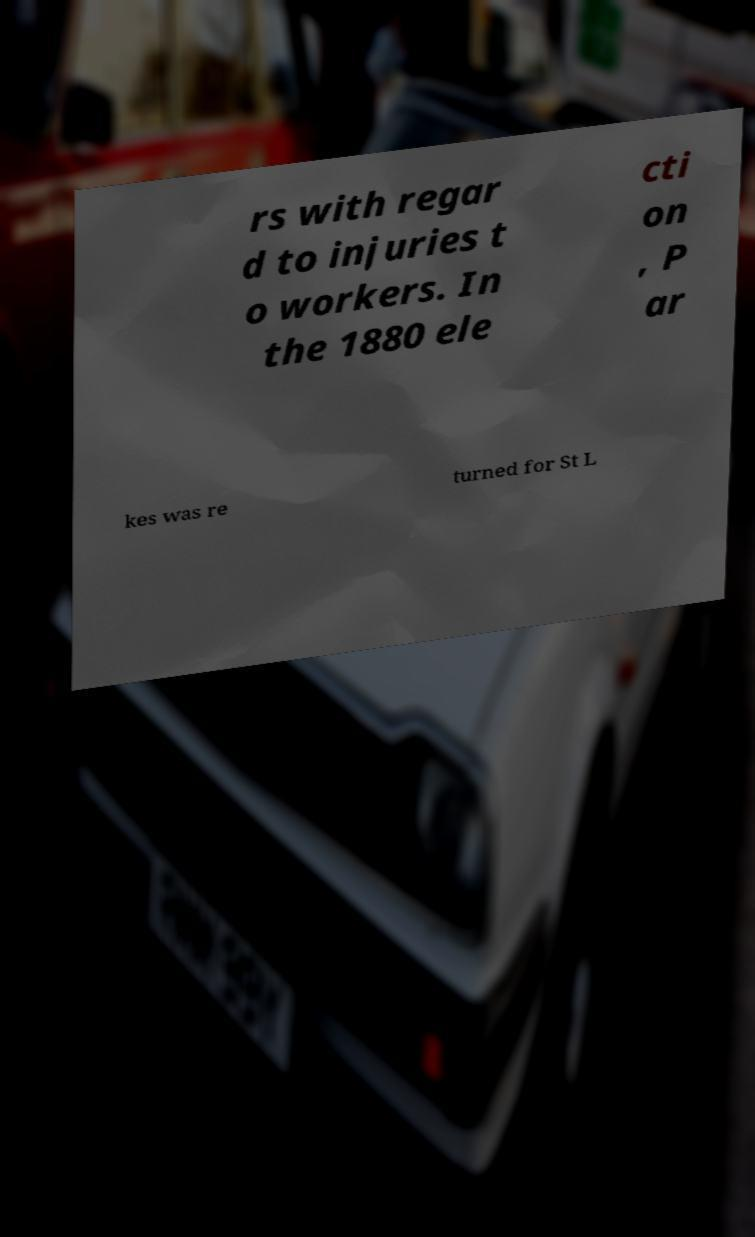What messages or text are displayed in this image? I need them in a readable, typed format. rs with regar d to injuries t o workers. In the 1880 ele cti on , P ar kes was re turned for St L 